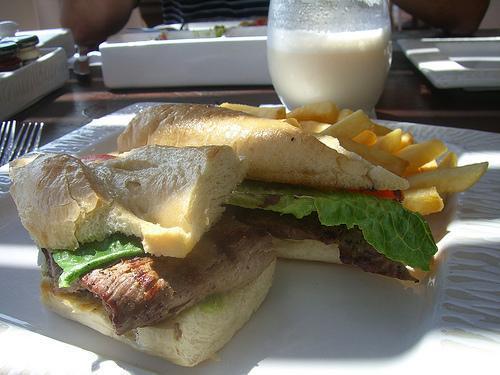How many beverages are in the picture?
Give a very brief answer. 1. 